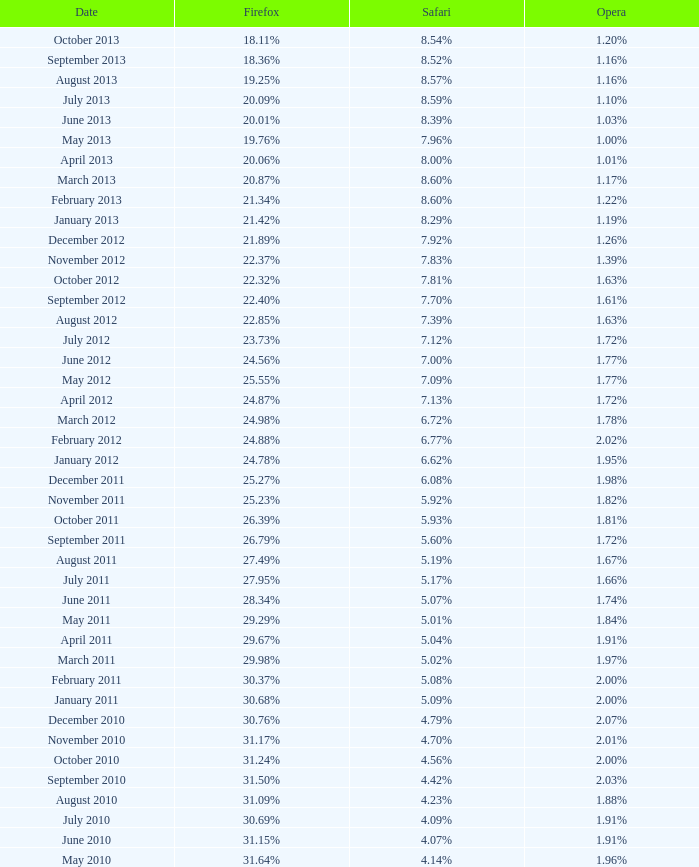What percentage of browsers were using Safari during the period in which 31.27% were using Firefox? 4.16%. 